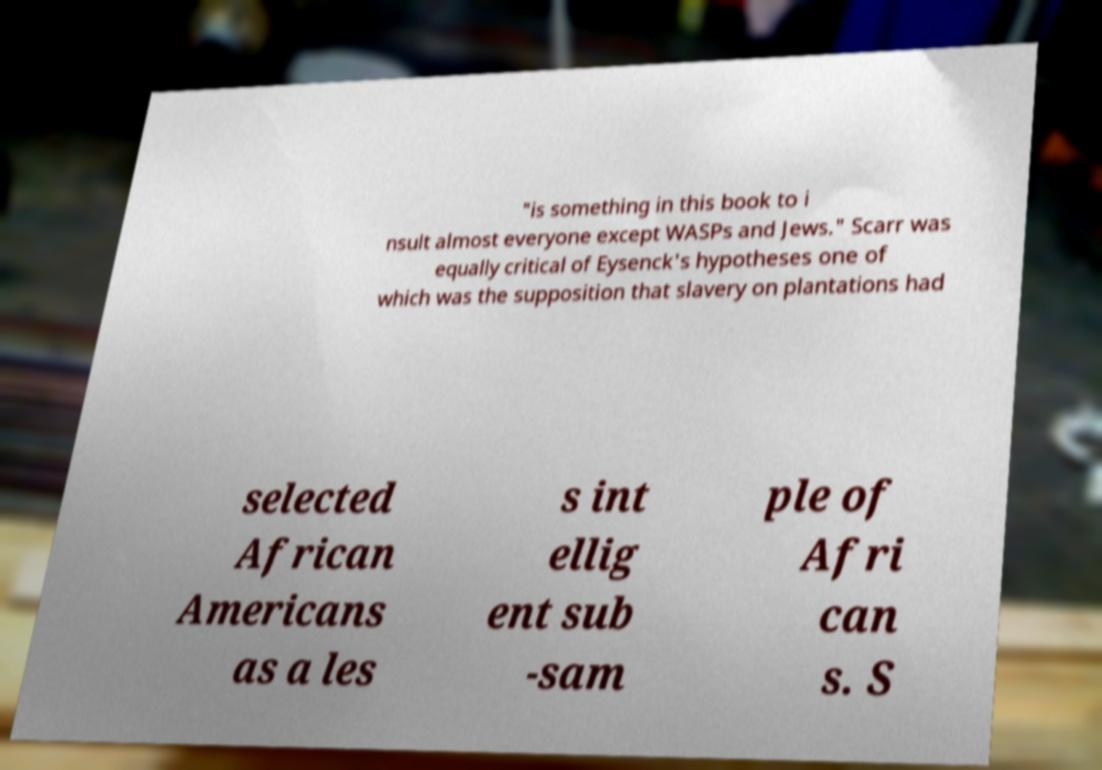I need the written content from this picture converted into text. Can you do that? "is something in this book to i nsult almost everyone except WASPs and Jews." Scarr was equally critical of Eysenck's hypotheses one of which was the supposition that slavery on plantations had selected African Americans as a les s int ellig ent sub -sam ple of Afri can s. S 